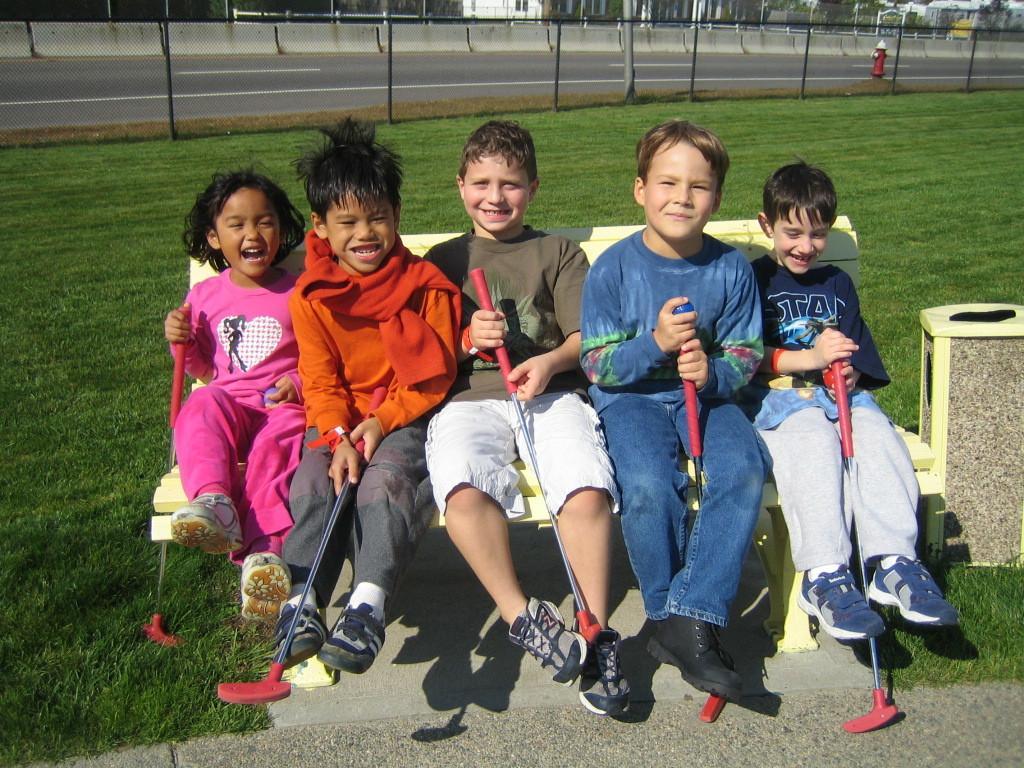Could you give a brief overview of what you see in this image? In this image in the center there are some children sitting on bench, and on the left side there is one box. At the bottom there is a walkway and grass, and in the background there are some poles, road, wall, trees and buildings and fire extinguisher. 